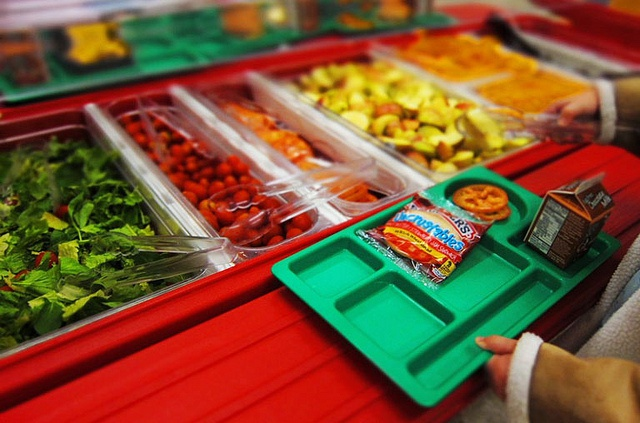Describe the objects in this image and their specific colors. I can see people in gray, brown, maroon, and black tones in this image. 